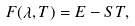Convert formula to latex. <formula><loc_0><loc_0><loc_500><loc_500>F ( \lambda , T ) = E - S T ,</formula> 